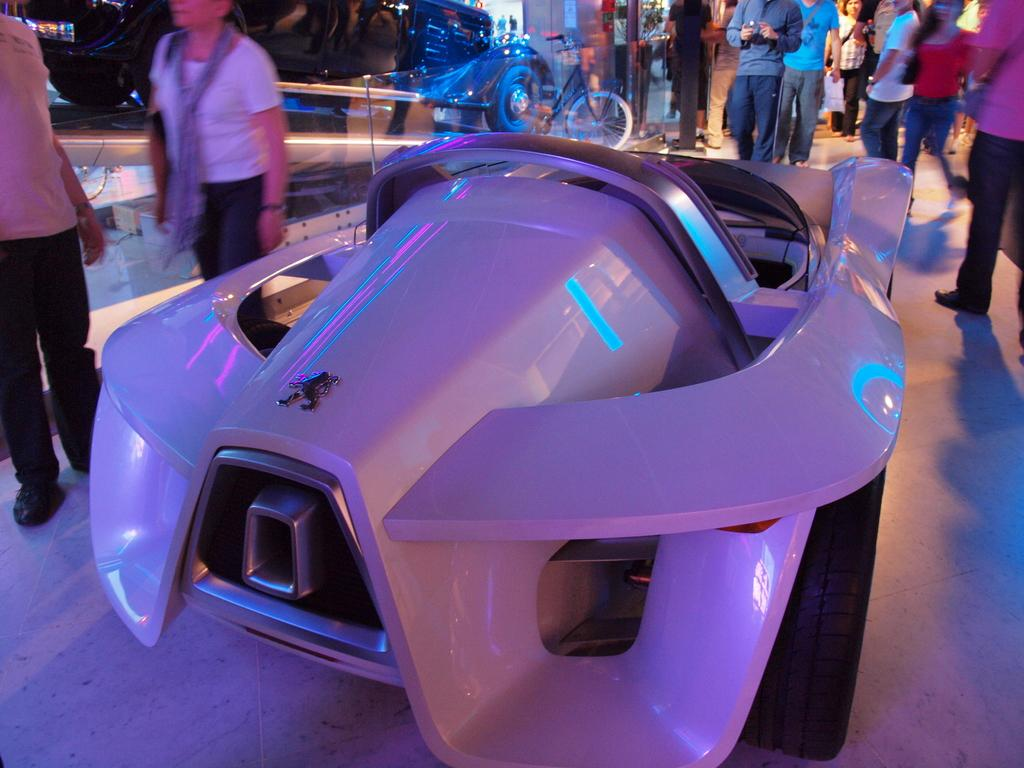What type of vehicle is in the image? There is a white car in the image. Where is the car located? The car is on the floor. What else can be seen in front of the car? There are people standing in front of the car. What other mode of transportation is present in the image? There is a bicycle in the image. How many trees can be seen growing from the car's roof in the image? There are no trees growing from the car's roof in the image. What type of gun is being held by the person standing in front of the car? There is no gun present in the image; only people, a car, and a bicycle are visible. 